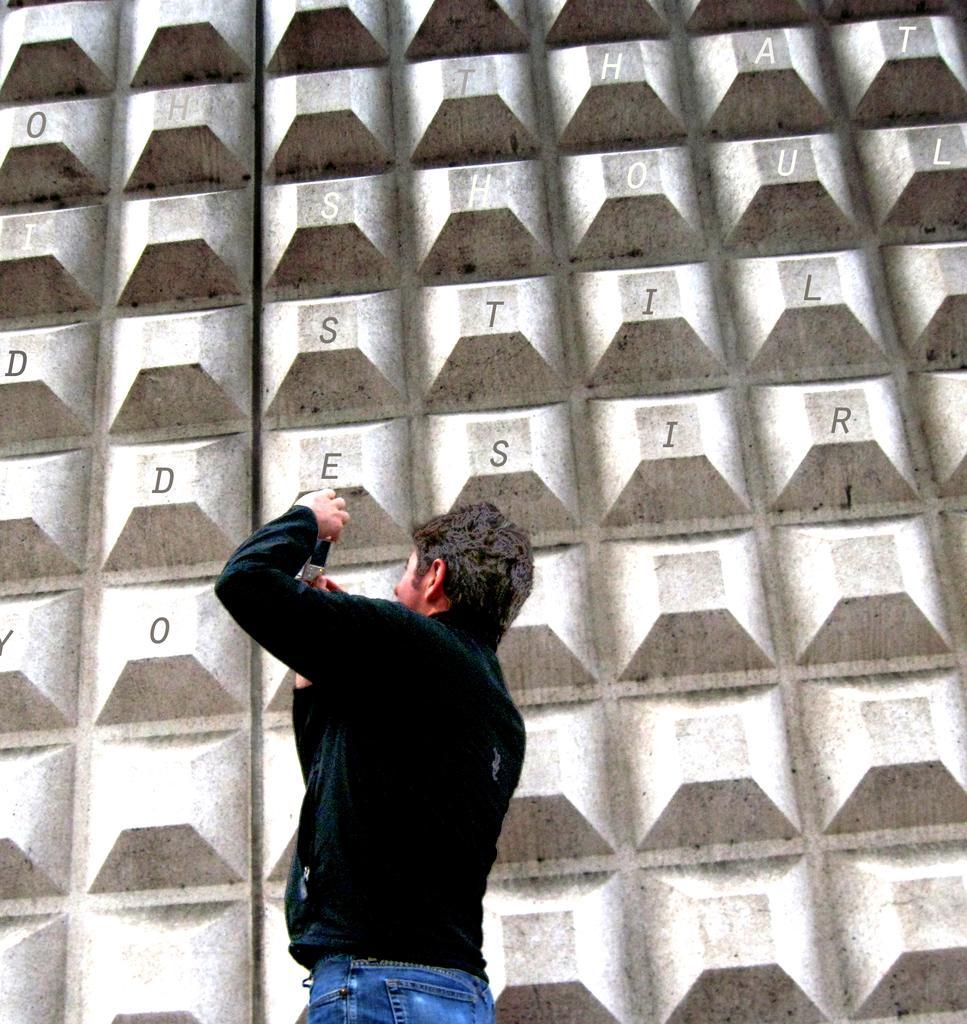Could you give a brief overview of what you see in this image? In the center of the image there is a person wearing a black color jacket. In the background of the image there is a wall with some text on it. 